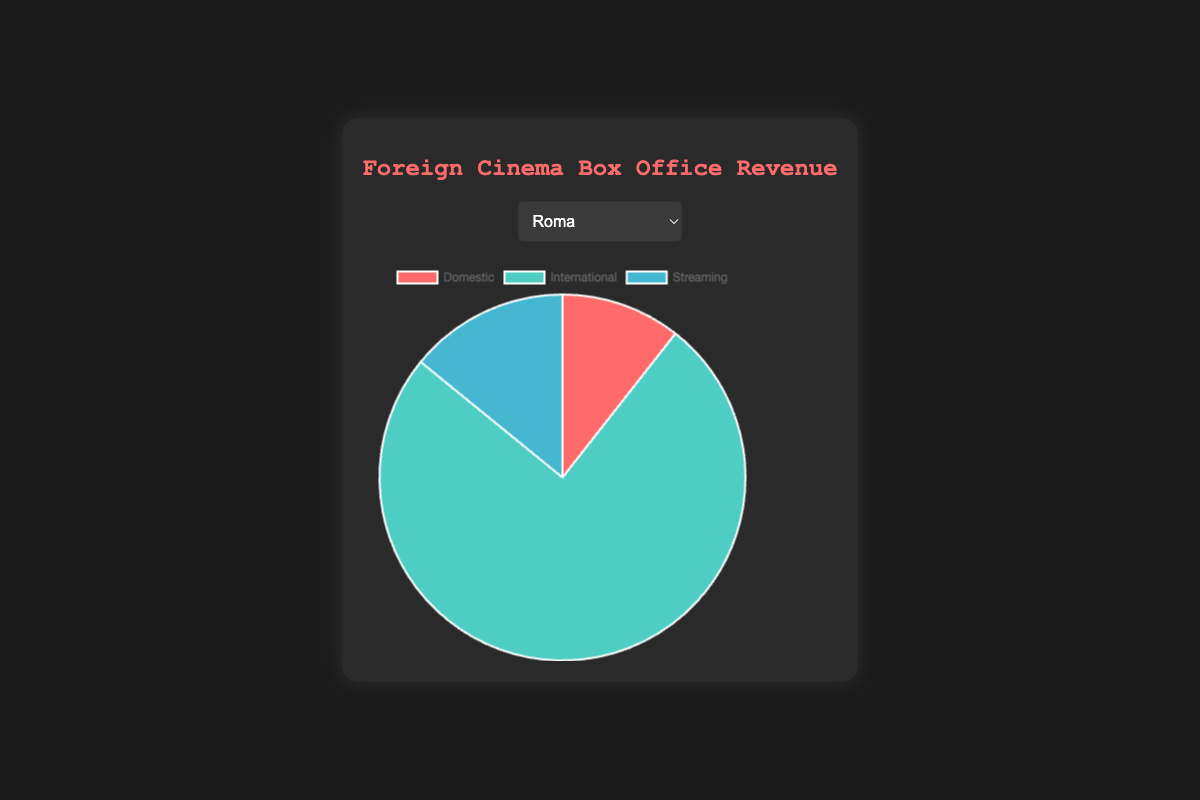What is the largest revenue source for "Roma"? From the pie chart of "Roma", the largest portion is "International" revenue.
Answer: International By how much does the international revenue of "Parasite" exceed its domestic revenue? The pie chart shows "Parasite" has $176,000,000 in international revenue and $53,000,000 in domestic revenue. The difference is $176,000,000 - $53,000,000.
Answer: $123,000,000 Which film has the highest streaming revenue? Referring to each pie chart, identify the film with the largest portion labeled as streaming revenue. "Parasite" has the highest streaming value of $18,000,000.
Answer: Parasite What percentage of "Pan's Labyrinth" total revenue comes from streaming? The pie chart indicates the revenue sources. First, calculate total revenue ($37,600,332 + $54,649,087 + $11,000,000). Then, determine the percentage of $11,000,000 out of the total revenue.
Answer: 9.88% Among all the films, which has the smallest international revenue? Compare the international revenue sections of all the pie charts. "The Handmaiden" has the smallest international revenue of $3,417,000.
Answer: The Handmaiden What is the combined domestic revenue of "Amélie" and "Shoplifters"? From the respective pie charts, the domestic revenue of "Amélie" is $33,195,000, and "Shoplifters" is $3,200,000. Add these values together.
Answer: $36,395,000 How does the proportion of international revenue compare between "Roma" and "Amélie"? Examine the proportion of international revenue relative to the total revenue in each pie chart. "Roma" has a larger relative proportion than "Amélie".
Answer: Roma has a larger proportion Which film has the smallest contribution from streaming as a percentage of its total revenue? Calculate the percentage of streaming revenue for each film by dividing the streaming revenue by the total revenue. "Amélie" has the smallest percentage as its streaming revenue is $1,250,000 out of the total.
Answer: Amélie What is the revenue difference between domestic and streaming for "Shoplifters"? "Shoplifters" has domestic revenue of $3,200,000 and streaming revenue of $1,200,000, thus the difference is $3,200,000 - $1,200,000.
Answer: $2,000,000 Which film generates more from streaming than from domestic revenue? Inspect each pie chart where the streaming revenue segment is larger than the domestic revenue segment. None of the films have a larger streaming revenue than domestic.
Answer: None 